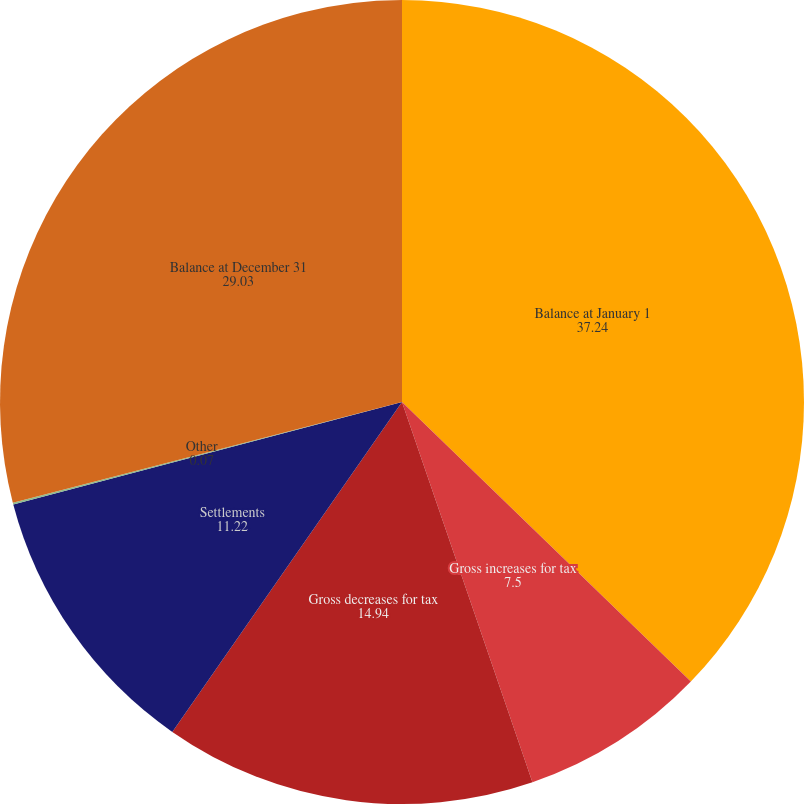Convert chart to OTSL. <chart><loc_0><loc_0><loc_500><loc_500><pie_chart><fcel>Balance at January 1<fcel>Gross increases for tax<fcel>Gross decreases for tax<fcel>Settlements<fcel>Other<fcel>Balance at December 31<nl><fcel>37.24%<fcel>7.5%<fcel>14.94%<fcel>11.22%<fcel>0.07%<fcel>29.03%<nl></chart> 